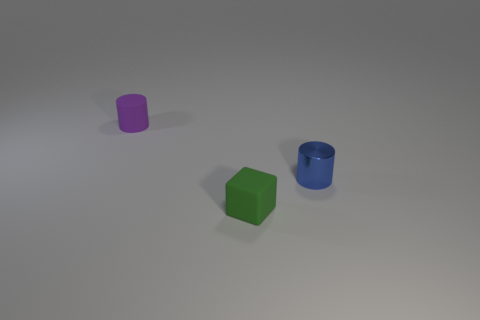Is there anything else that has the same material as the blue object?
Your answer should be compact. No. Is there any other thing that has the same shape as the green object?
Make the answer very short. No. What shape is the tiny rubber object in front of the cylinder that is right of the small purple cylinder?
Your answer should be very brief. Cube. There is a purple cylinder; how many cylinders are to the right of it?
Your response must be concise. 1. Are there any small green objects made of the same material as the tiny purple object?
Provide a short and direct response. Yes. What is the material of the other cylinder that is the same size as the purple matte cylinder?
Your answer should be very brief. Metal. What is the size of the object that is on the left side of the small blue metal object and in front of the small purple cylinder?
Ensure brevity in your answer.  Small. The small thing that is right of the purple rubber cylinder and behind the green block is what color?
Ensure brevity in your answer.  Blue. Is the number of tiny rubber objects on the right side of the tiny blue cylinder less than the number of rubber cylinders that are left of the tiny green block?
Keep it short and to the point. Yes. How many blue shiny things have the same shape as the small purple rubber thing?
Give a very brief answer. 1. 